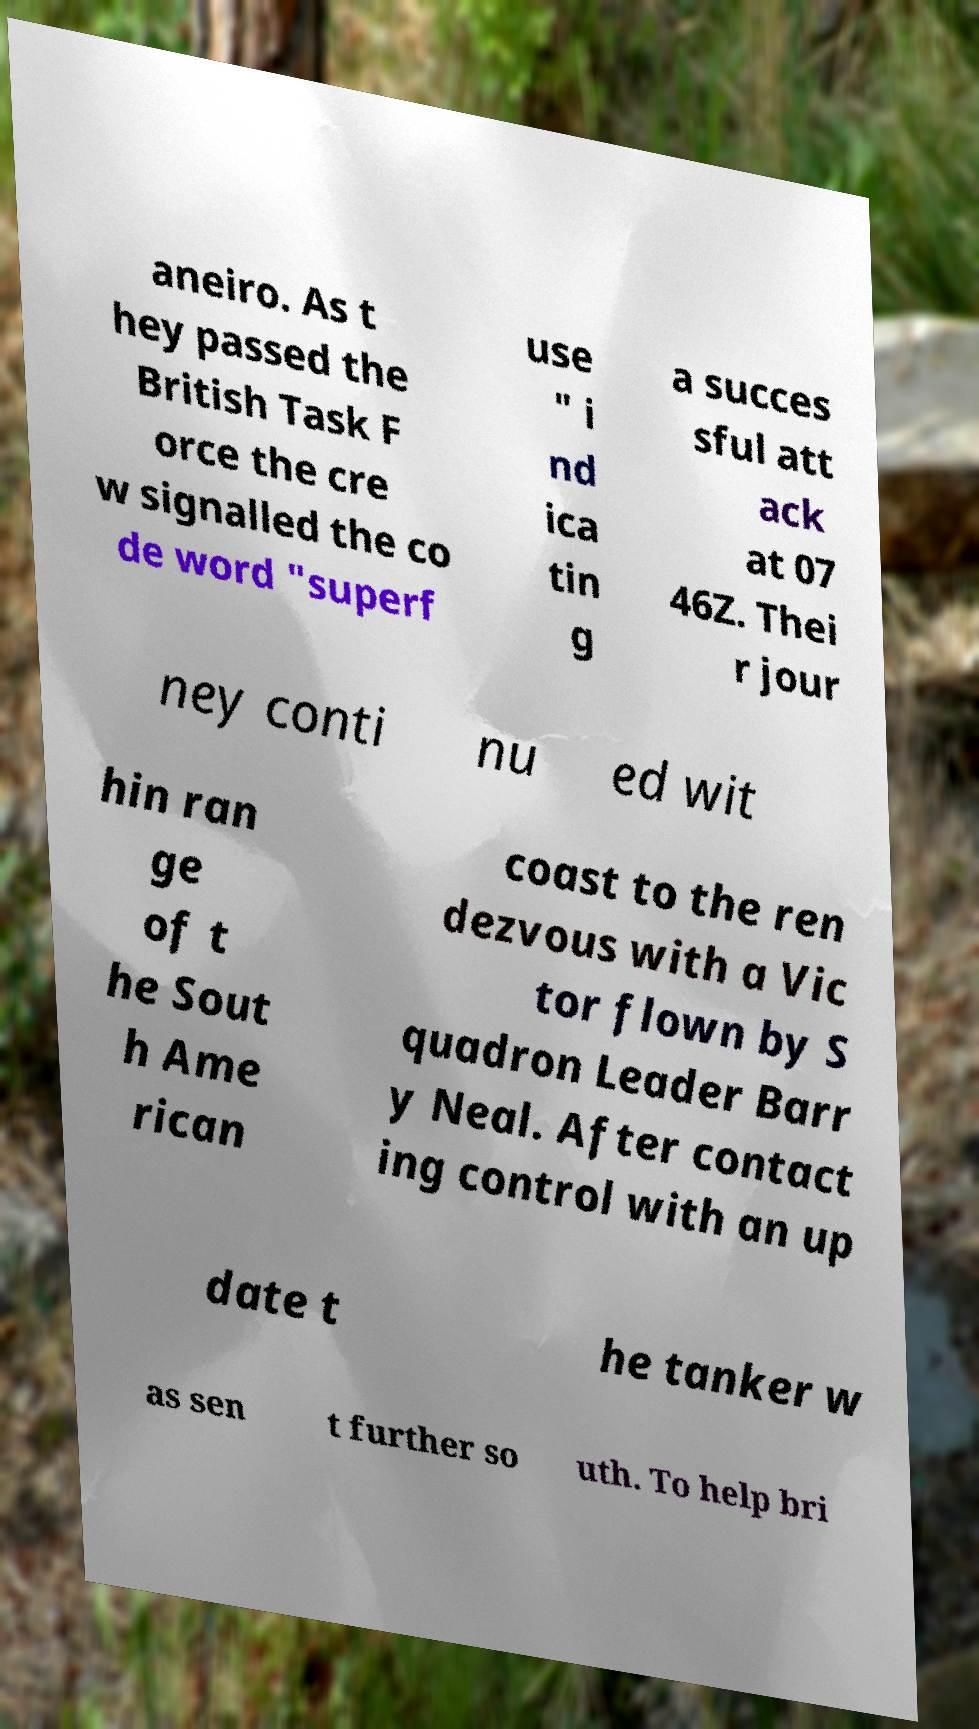Please identify and transcribe the text found in this image. aneiro. As t hey passed the British Task F orce the cre w signalled the co de word "superf use " i nd ica tin g a succes sful att ack at 07 46Z. Thei r jour ney conti nu ed wit hin ran ge of t he Sout h Ame rican coast to the ren dezvous with a Vic tor flown by S quadron Leader Barr y Neal. After contact ing control with an up date t he tanker w as sen t further so uth. To help bri 